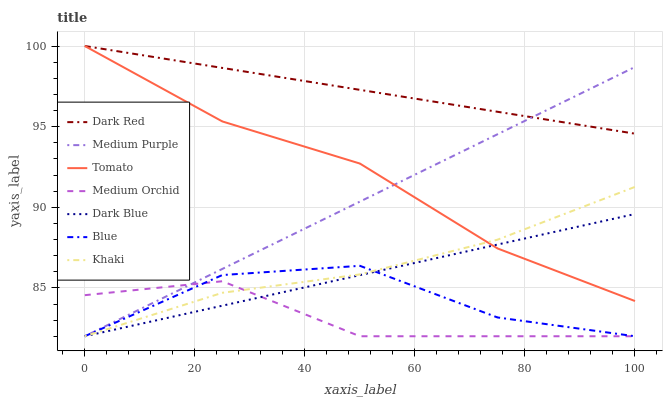Does Medium Orchid have the minimum area under the curve?
Answer yes or no. Yes. Does Dark Red have the maximum area under the curve?
Answer yes or no. Yes. Does Blue have the minimum area under the curve?
Answer yes or no. No. Does Blue have the maximum area under the curve?
Answer yes or no. No. Is Dark Red the smoothest?
Answer yes or no. Yes. Is Blue the roughest?
Answer yes or no. Yes. Is Khaki the smoothest?
Answer yes or no. No. Is Khaki the roughest?
Answer yes or no. No. Does Blue have the lowest value?
Answer yes or no. Yes. Does Dark Red have the lowest value?
Answer yes or no. No. Does Dark Red have the highest value?
Answer yes or no. Yes. Does Blue have the highest value?
Answer yes or no. No. Is Medium Orchid less than Tomato?
Answer yes or no. Yes. Is Dark Red greater than Blue?
Answer yes or no. Yes. Does Dark Red intersect Medium Purple?
Answer yes or no. Yes. Is Dark Red less than Medium Purple?
Answer yes or no. No. Is Dark Red greater than Medium Purple?
Answer yes or no. No. Does Medium Orchid intersect Tomato?
Answer yes or no. No. 